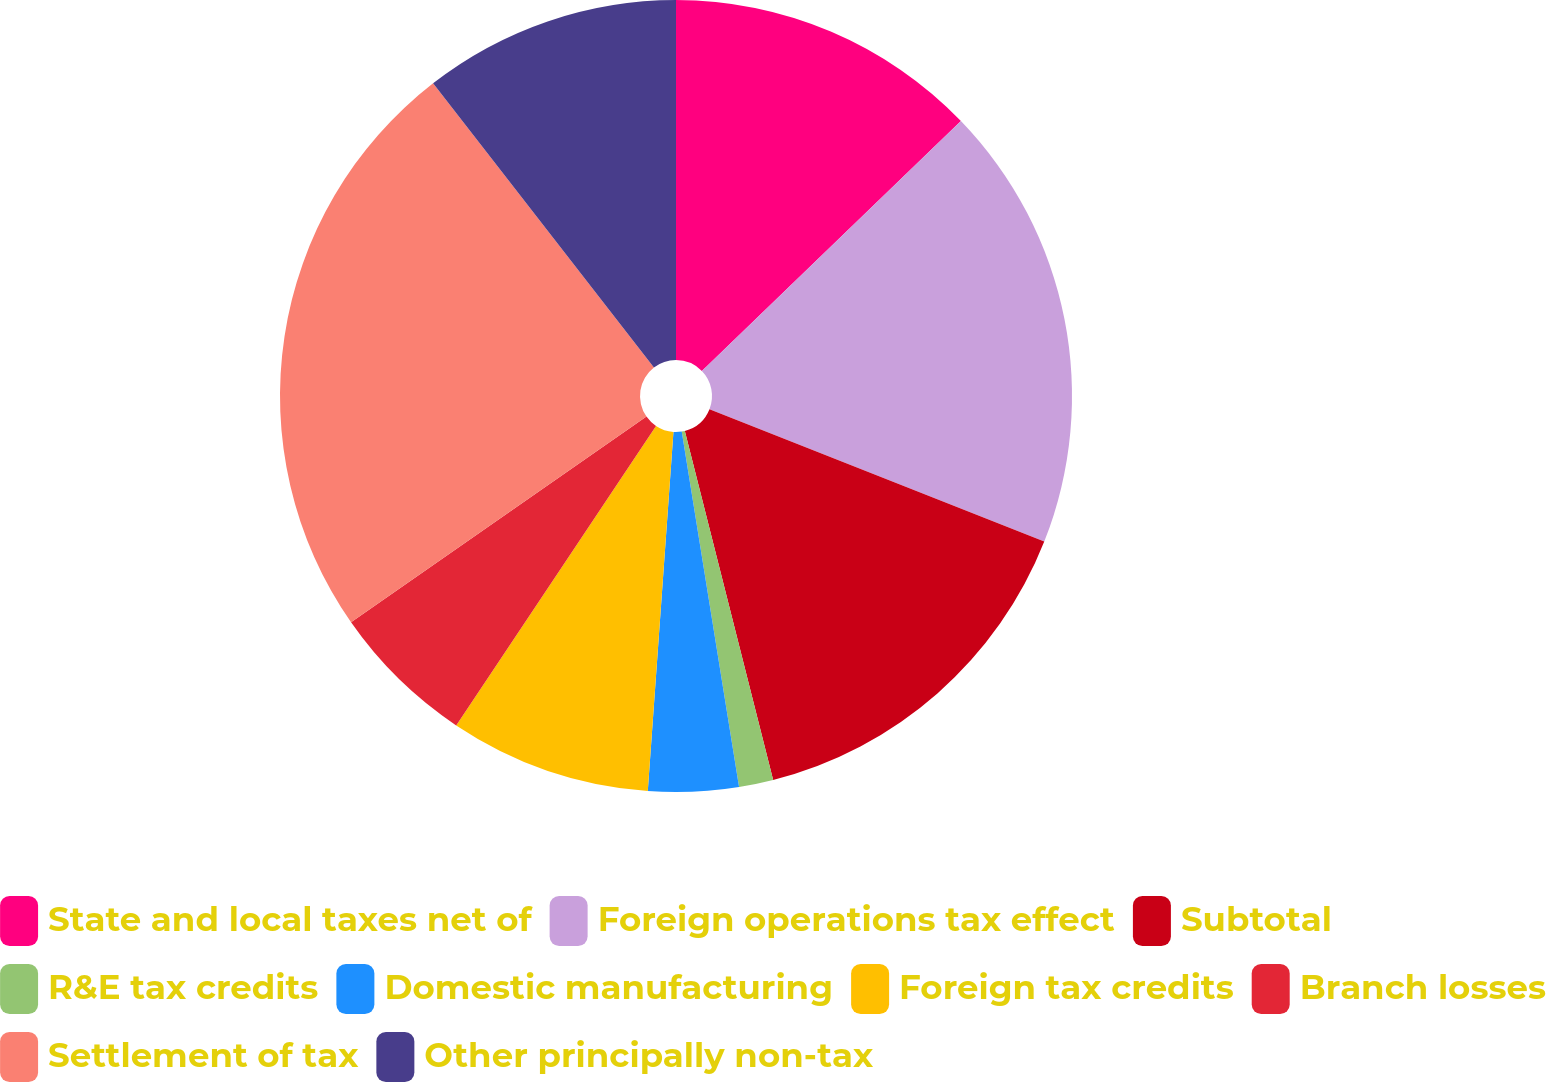Convert chart. <chart><loc_0><loc_0><loc_500><loc_500><pie_chart><fcel>State and local taxes net of<fcel>Foreign operations tax effect<fcel>Subtotal<fcel>R&E tax credits<fcel>Domestic manufacturing<fcel>Foreign tax credits<fcel>Branch losses<fcel>Settlement of tax<fcel>Other principally non-tax<nl><fcel>12.78%<fcel>18.21%<fcel>15.06%<fcel>1.4%<fcel>3.68%<fcel>8.23%<fcel>5.95%<fcel>24.17%<fcel>10.51%<nl></chart> 